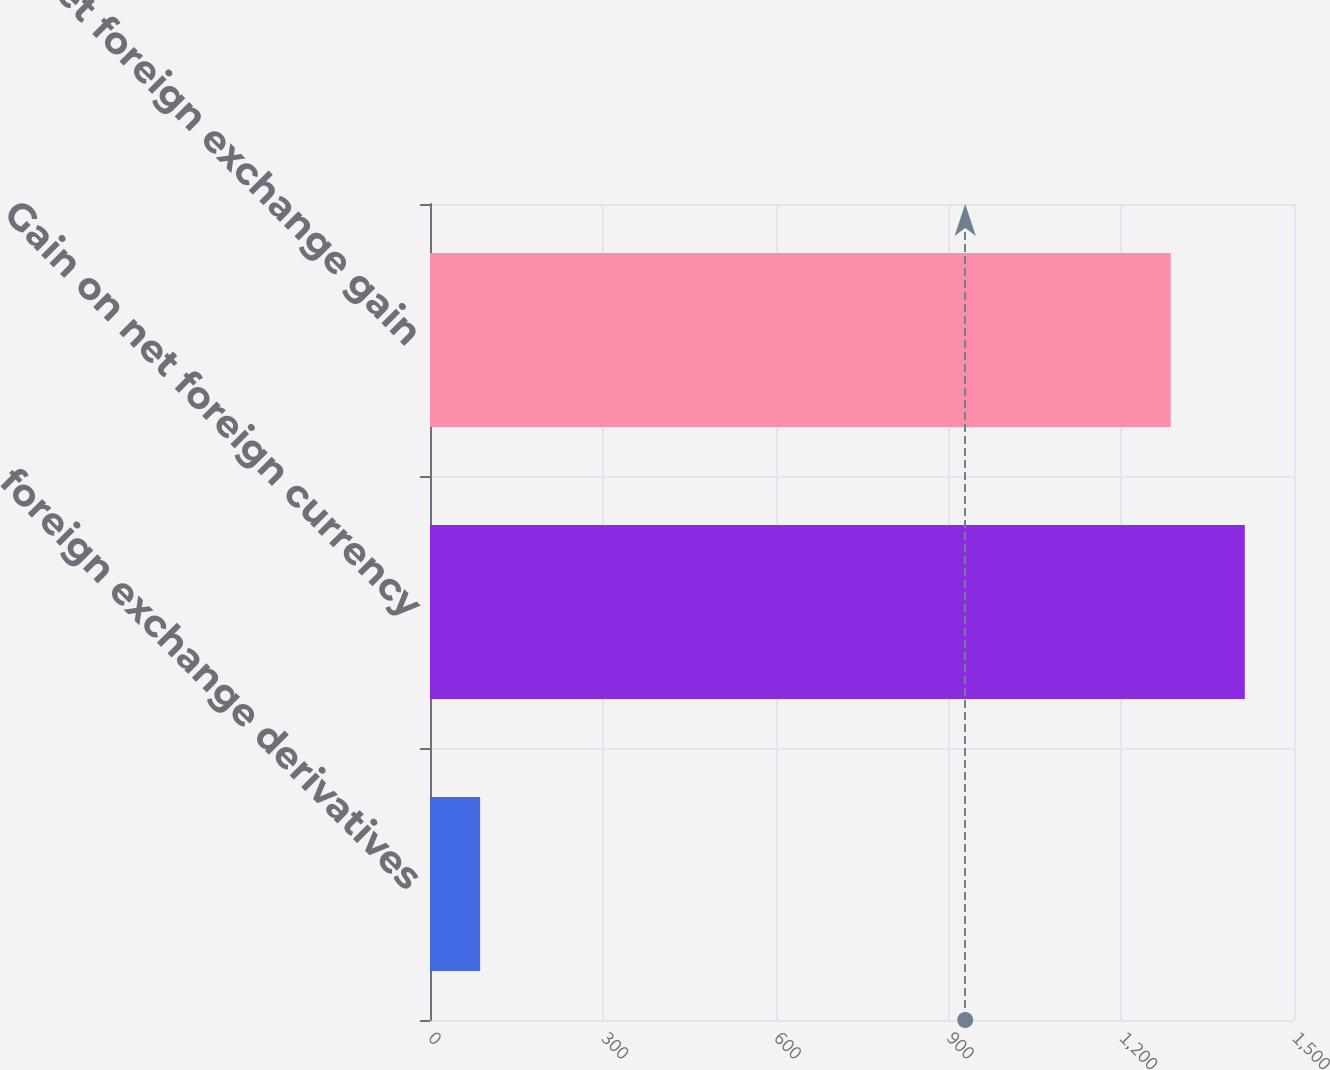Convert chart. <chart><loc_0><loc_0><loc_500><loc_500><bar_chart><fcel>foreign exchange derivatives<fcel>Gain on net foreign currency<fcel>Net foreign exchange gain<nl><fcel>87<fcel>1414.6<fcel>1286<nl></chart> 